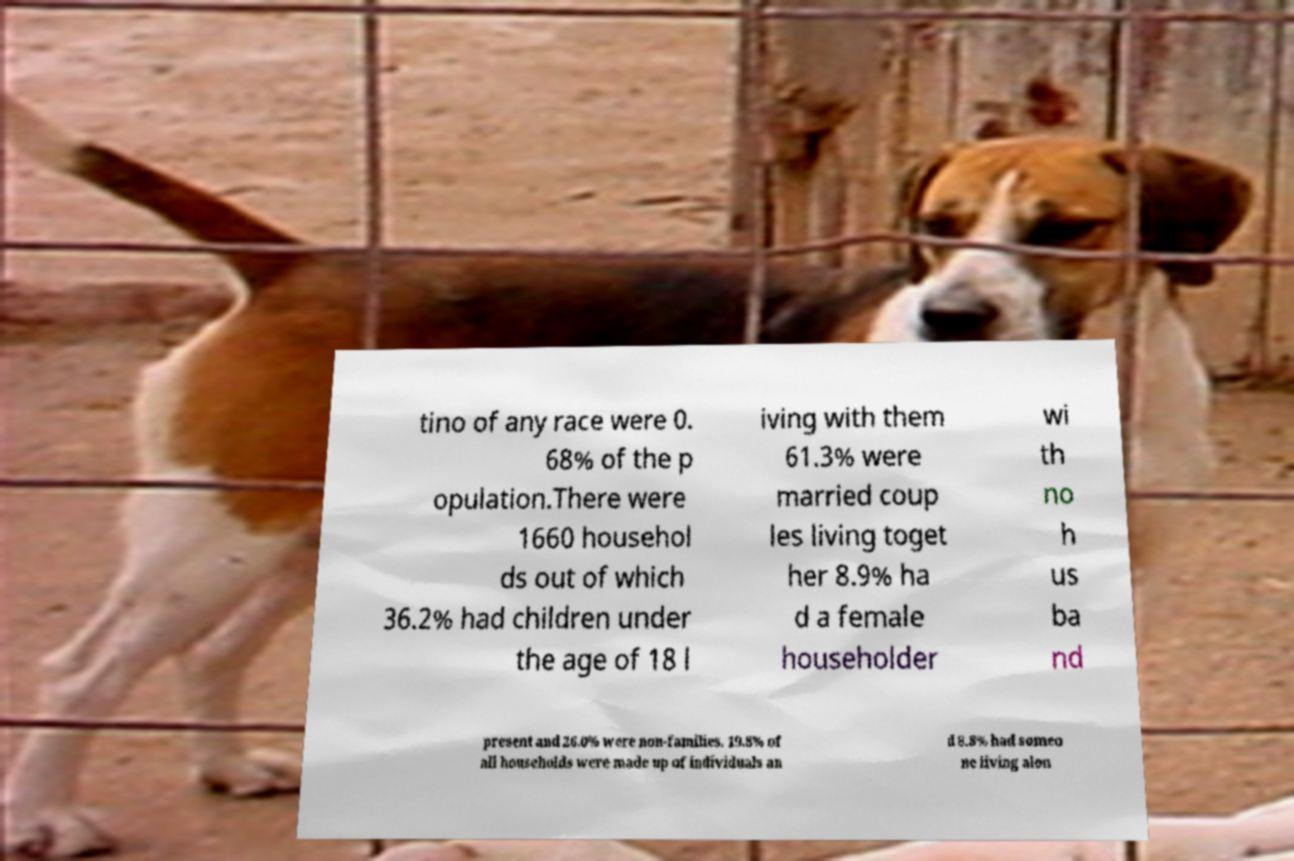Can you read and provide the text displayed in the image?This photo seems to have some interesting text. Can you extract and type it out for me? tino of any race were 0. 68% of the p opulation.There were 1660 househol ds out of which 36.2% had children under the age of 18 l iving with them 61.3% were married coup les living toget her 8.9% ha d a female householder wi th no h us ba nd present and 26.0% were non-families. 19.8% of all households were made up of individuals an d 8.8% had someo ne living alon 